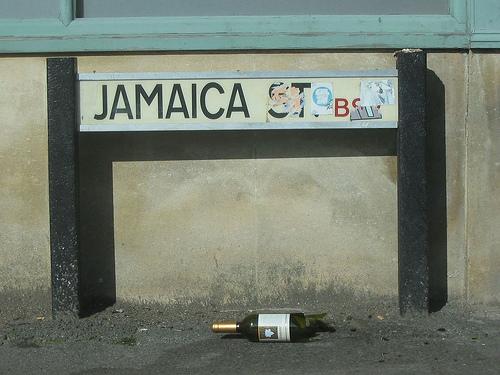Where was this photo taken?
Give a very brief answer. Jamaica. What is the third letter in the street name?
Concise answer only. M. What three letter word is on the bottle on the left?
Answer briefly. Jam. What is wrong with the bottle on the ground?
Short answer required. Broken. 